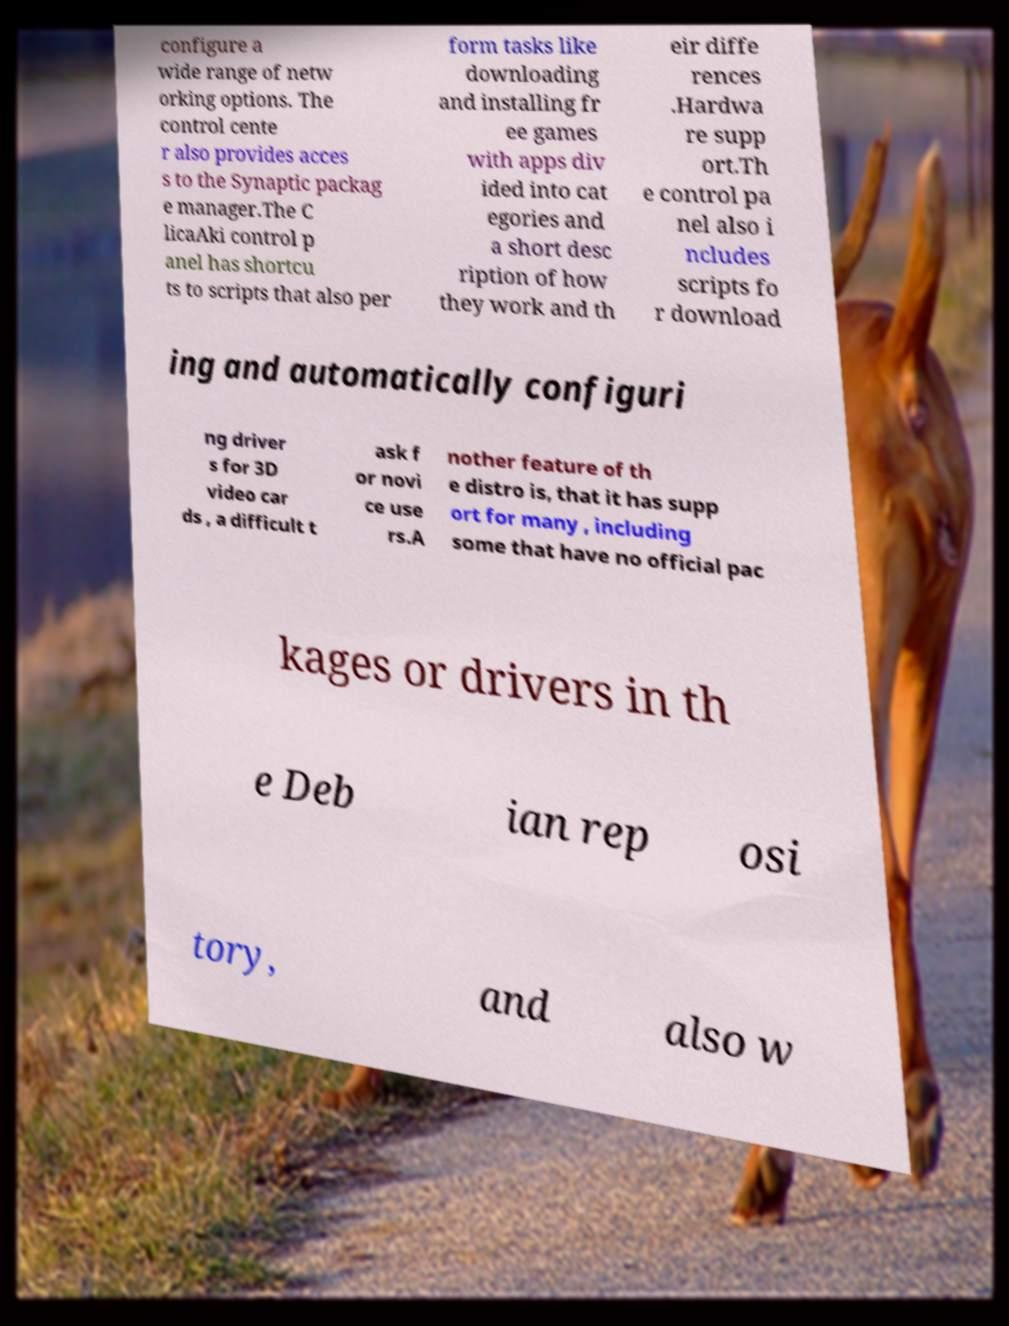Could you assist in decoding the text presented in this image and type it out clearly? configure a wide range of netw orking options. The control cente r also provides acces s to the Synaptic packag e manager.The C licaAki control p anel has shortcu ts to scripts that also per form tasks like downloading and installing fr ee games with apps div ided into cat egories and a short desc ription of how they work and th eir diffe rences .Hardwa re supp ort.Th e control pa nel also i ncludes scripts fo r download ing and automatically configuri ng driver s for 3D video car ds , a difficult t ask f or novi ce use rs.A nother feature of th e distro is, that it has supp ort for many , including some that have no official pac kages or drivers in th e Deb ian rep osi tory, and also w 